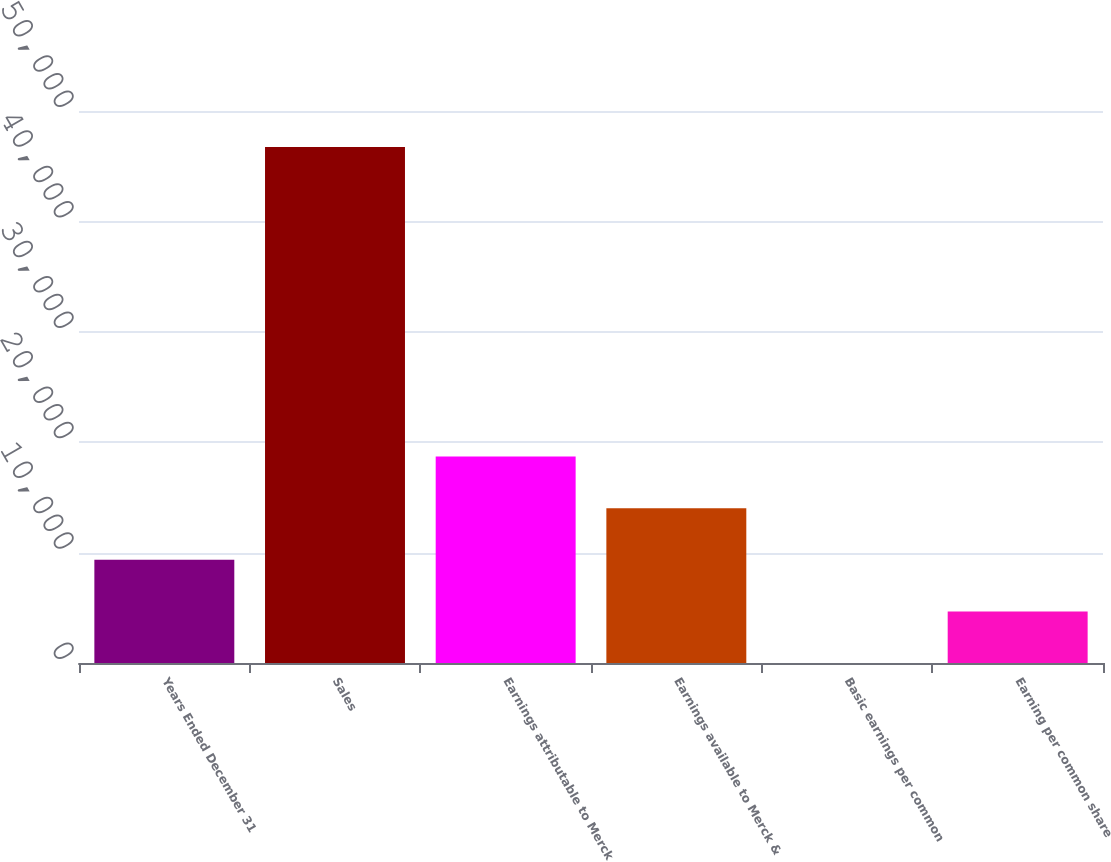Convert chart. <chart><loc_0><loc_0><loc_500><loc_500><bar_chart><fcel>Years Ended December 31<fcel>Sales<fcel>Earnings attributable to Merck<fcel>Earnings available to Merck &<fcel>Basic earnings per common<fcel>Earning per common share<nl><fcel>9350.66<fcel>46749.6<fcel>18700.4<fcel>14025.5<fcel>0.92<fcel>4675.79<nl></chart> 